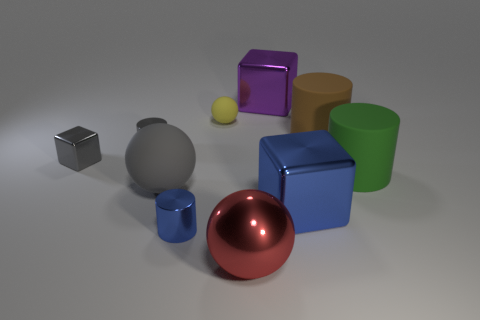How does the lighting in the image affect the appearance of the objects? The lighting in the image casts soft shadows and highlights the reflective quality of the surfaces, enhancing the three-dimensional perception of the objects and contributing to the realism of the scene. 